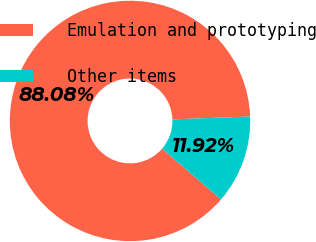Convert chart to OTSL. <chart><loc_0><loc_0><loc_500><loc_500><pie_chart><fcel>Emulation and prototyping<fcel>Other items<nl><fcel>88.08%<fcel>11.92%<nl></chart> 